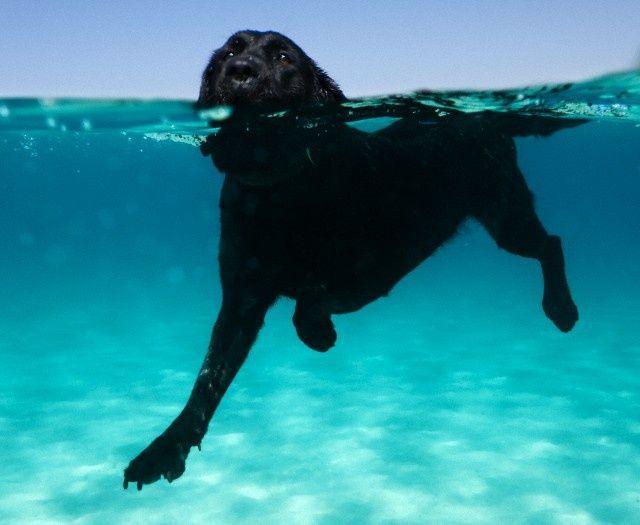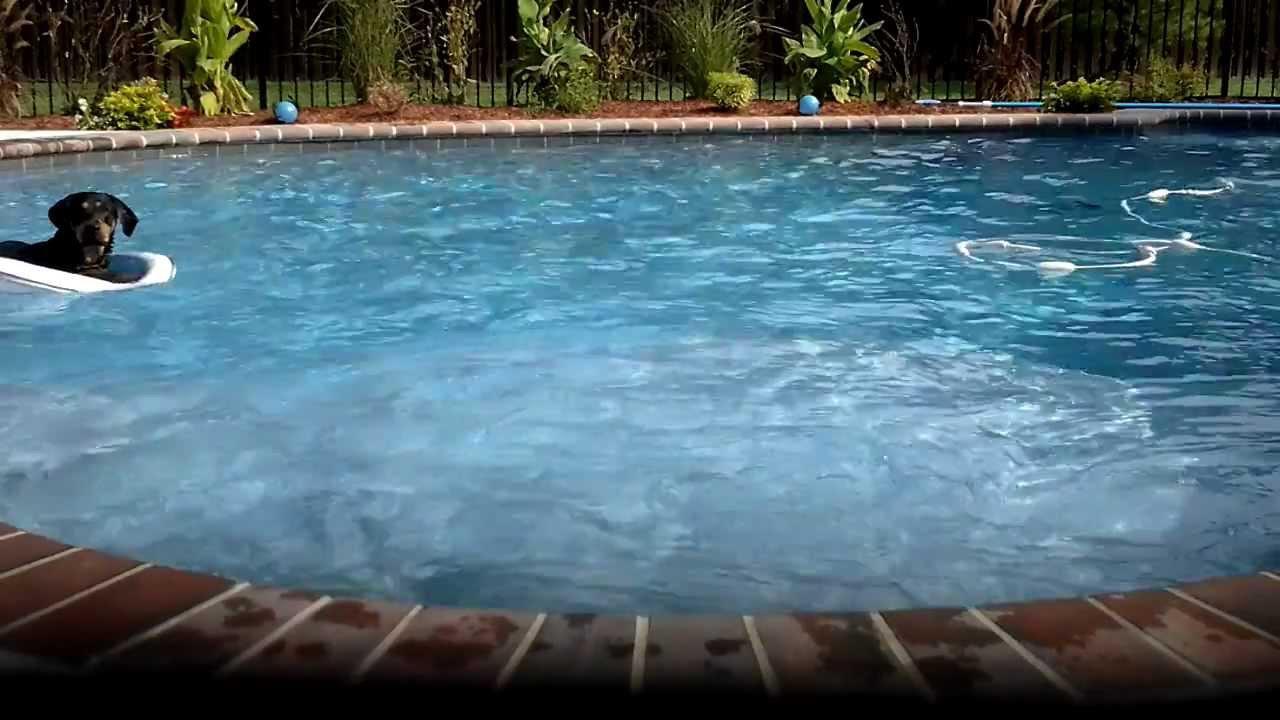The first image is the image on the left, the second image is the image on the right. For the images shown, is this caption "A black dog is floating on something yellow in a pool." true? Answer yes or no. No. The first image is the image on the left, the second image is the image on the right. Considering the images on both sides, is "One dog is swimming." valid? Answer yes or no. Yes. 